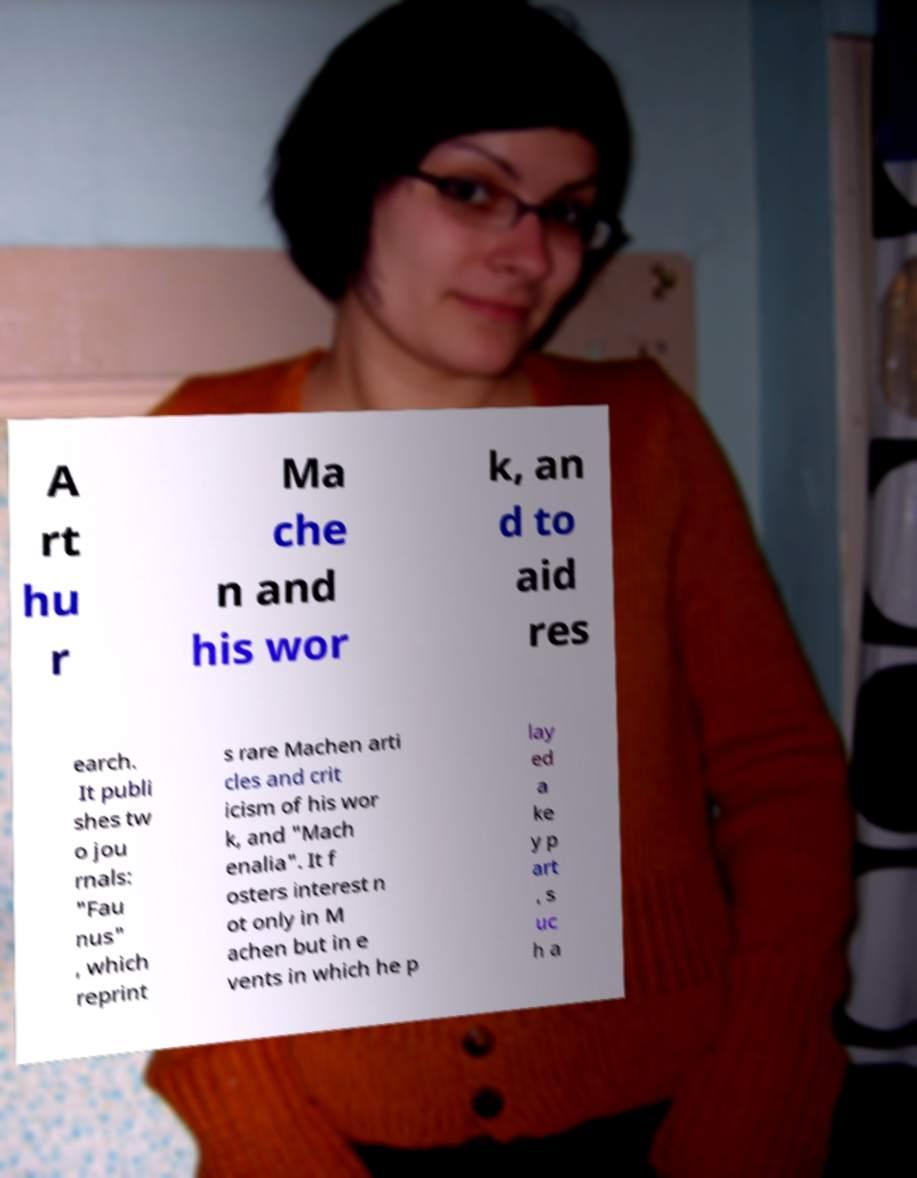Please read and relay the text visible in this image. What does it say? A rt hu r Ma che n and his wor k, an d to aid res earch. It publi shes tw o jou rnals: "Fau nus" , which reprint s rare Machen arti cles and crit icism of his wor k, and "Mach enalia". It f osters interest n ot only in M achen but in e vents in which he p lay ed a ke y p art , s uc h a 